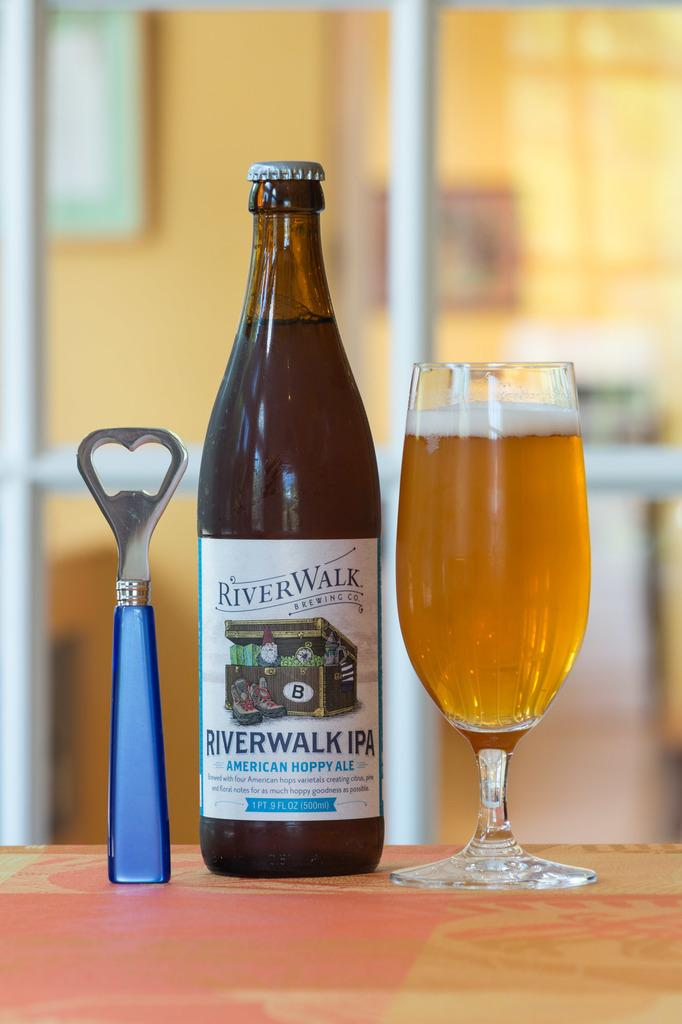<image>
Share a concise interpretation of the image provided. A bottle opener, bottle of River WALK IPA Ale and a glass of beer! 